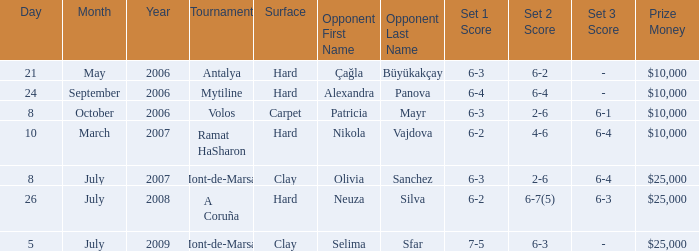What is the date of the match on clay with score of 6-3 2-6 6-4? July 8, 2007. 